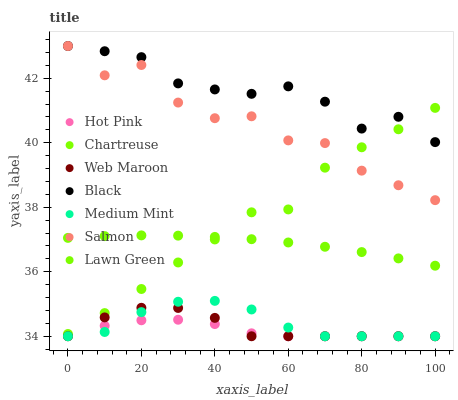Does Hot Pink have the minimum area under the curve?
Answer yes or no. Yes. Does Black have the maximum area under the curve?
Answer yes or no. Yes. Does Lawn Green have the minimum area under the curve?
Answer yes or no. No. Does Lawn Green have the maximum area under the curve?
Answer yes or no. No. Is Lawn Green the smoothest?
Answer yes or no. Yes. Is Salmon the roughest?
Answer yes or no. Yes. Is Salmon the smoothest?
Answer yes or no. No. Is Lawn Green the roughest?
Answer yes or no. No. Does Medium Mint have the lowest value?
Answer yes or no. Yes. Does Lawn Green have the lowest value?
Answer yes or no. No. Does Black have the highest value?
Answer yes or no. Yes. Does Lawn Green have the highest value?
Answer yes or no. No. Is Hot Pink less than Salmon?
Answer yes or no. Yes. Is Chartreuse greater than Hot Pink?
Answer yes or no. Yes. Does Web Maroon intersect Hot Pink?
Answer yes or no. Yes. Is Web Maroon less than Hot Pink?
Answer yes or no. No. Is Web Maroon greater than Hot Pink?
Answer yes or no. No. Does Hot Pink intersect Salmon?
Answer yes or no. No. 